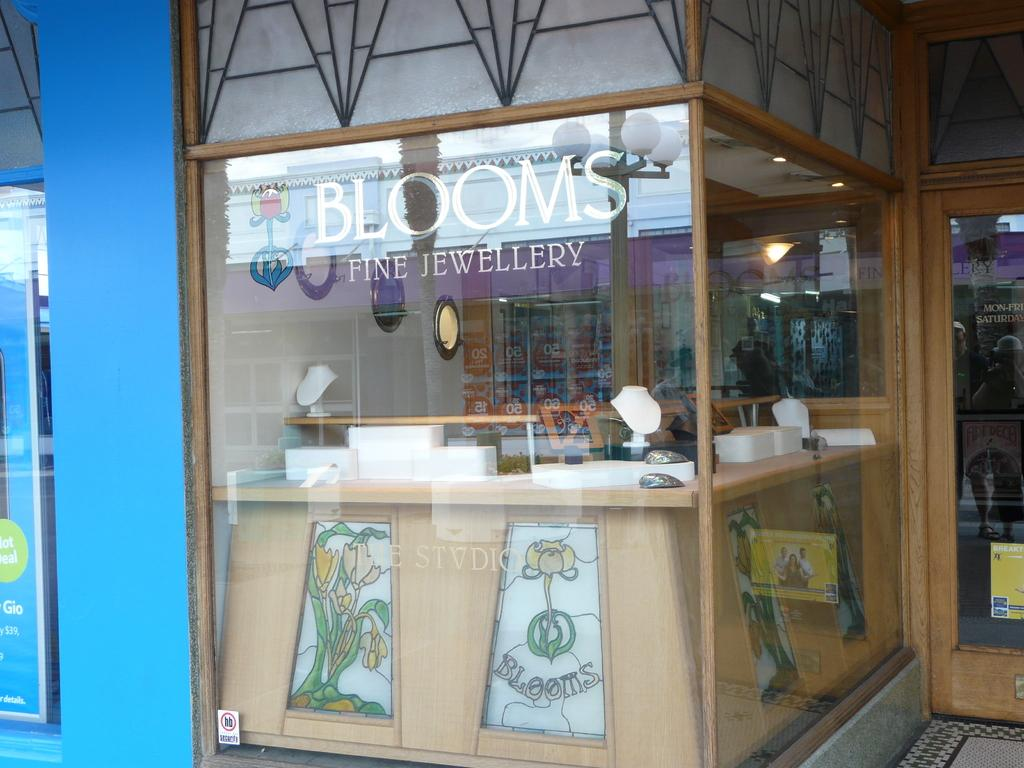Provide a one-sentence caption for the provided image. A window looking into Blooms Fine Jewelry store. 